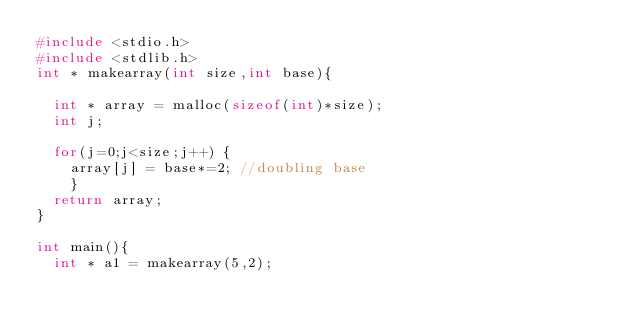<code> <loc_0><loc_0><loc_500><loc_500><_C_>#include <stdio.h>
#include <stdlib.h>
int * makearray(int size,int base){

  int * array = malloc(sizeof(int)*size);
  int j;

  for(j=0;j<size;j++) {
    array[j] = base*=2; //doubling base
    }
  return array;
}

int main(){
  int * a1 = makearray(5,2);</code> 